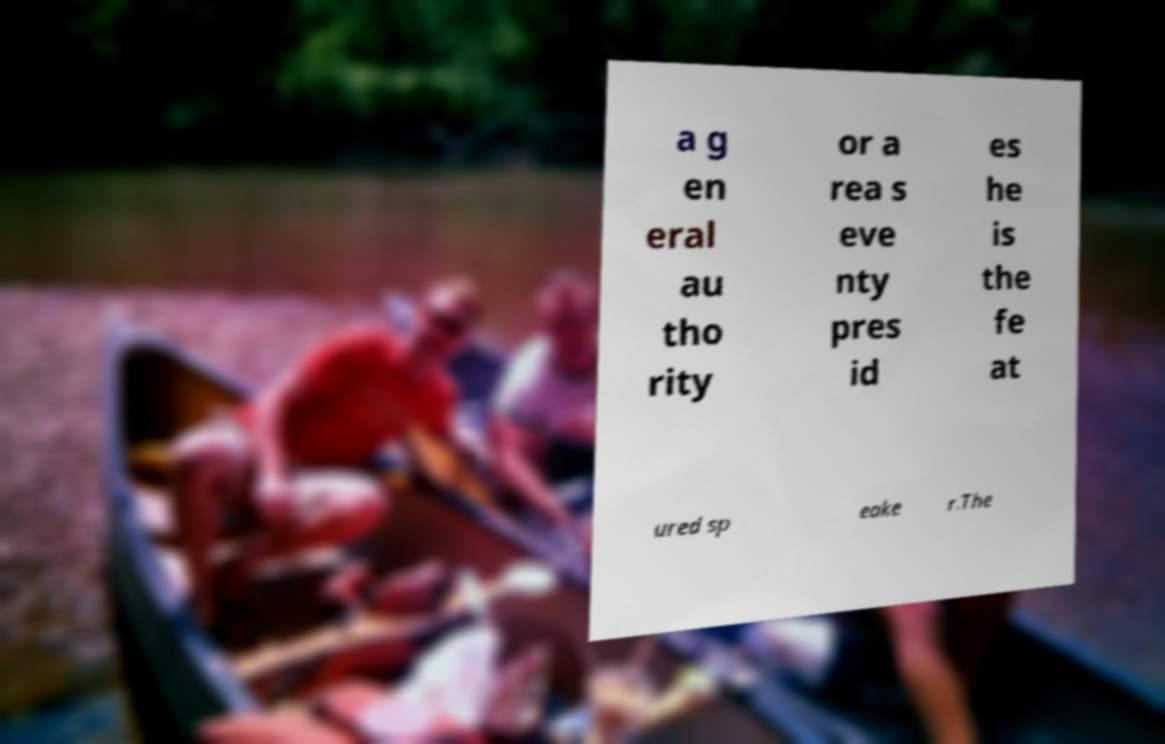Could you assist in decoding the text presented in this image and type it out clearly? a g en eral au tho rity or a rea s eve nty pres id es he is the fe at ured sp eake r.The 